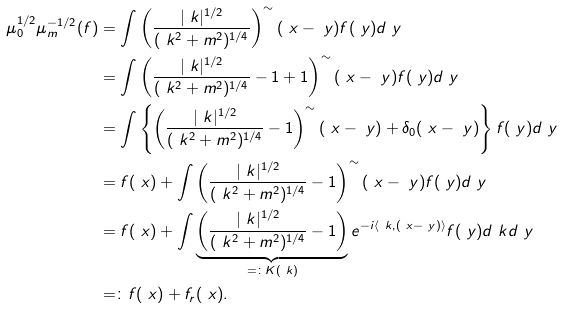Convert formula to latex. <formula><loc_0><loc_0><loc_500><loc_500>\mu _ { 0 } ^ { 1 / 2 } \mu _ { m } ^ { - 1 / 2 } ( f ) & = \int \left ( \frac { | \ k | ^ { 1 / 2 } } { ( \ k ^ { 2 } + m ^ { 2 } ) ^ { 1 / 4 } } \right ) ^ { \sim } ( \ x - \ y ) f ( \ y ) d \ y \\ & = \int \left ( \frac { | \ k | ^ { 1 / 2 } } { ( \ k ^ { 2 } + m ^ { 2 } ) ^ { 1 / 4 } } - 1 + 1 \right ) ^ { \sim } ( \ x - \ y ) f ( \ y ) d \ y \\ & = \int \left \{ \left ( \frac { | \ k | ^ { 1 / 2 } } { ( \ k ^ { 2 } + m ^ { 2 } ) ^ { 1 / 4 } } - 1 \right ) ^ { \sim } ( \ x - \ y ) + \delta _ { 0 } ( \ x - \ y ) \right \} f ( \ y ) d \ y \\ & = f ( \ x ) + \int \left ( \frac { | \ k | ^ { 1 / 2 } } { ( \ k ^ { 2 } + m ^ { 2 } ) ^ { 1 / 4 } } - 1 \right ) ^ { \sim } ( \ x - \ y ) f ( \ y ) d \ y \\ & = f ( \ x ) + \int \underbrace { \left ( \frac { | \ k | ^ { 1 / 2 } } { ( \ k ^ { 2 } + m ^ { 2 } ) ^ { 1 / 4 } } - 1 \right ) } _ { = \colon K ( \ k ) } e ^ { - i \langle \ k , ( \ x - \ y ) \rangle } f ( \ y ) d \ k d \ y \\ & = \colon f ( \ x ) + f _ { r } ( \ x ) .</formula> 